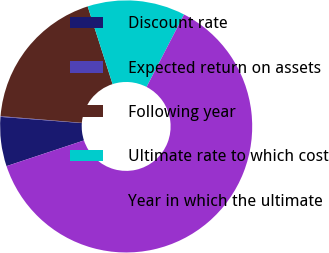Convert chart. <chart><loc_0><loc_0><loc_500><loc_500><pie_chart><fcel>Discount rate<fcel>Expected return on assets<fcel>Following year<fcel>Ultimate rate to which cost<fcel>Year in which the ultimate<nl><fcel>6.31%<fcel>0.09%<fcel>18.76%<fcel>12.53%<fcel>62.3%<nl></chart> 